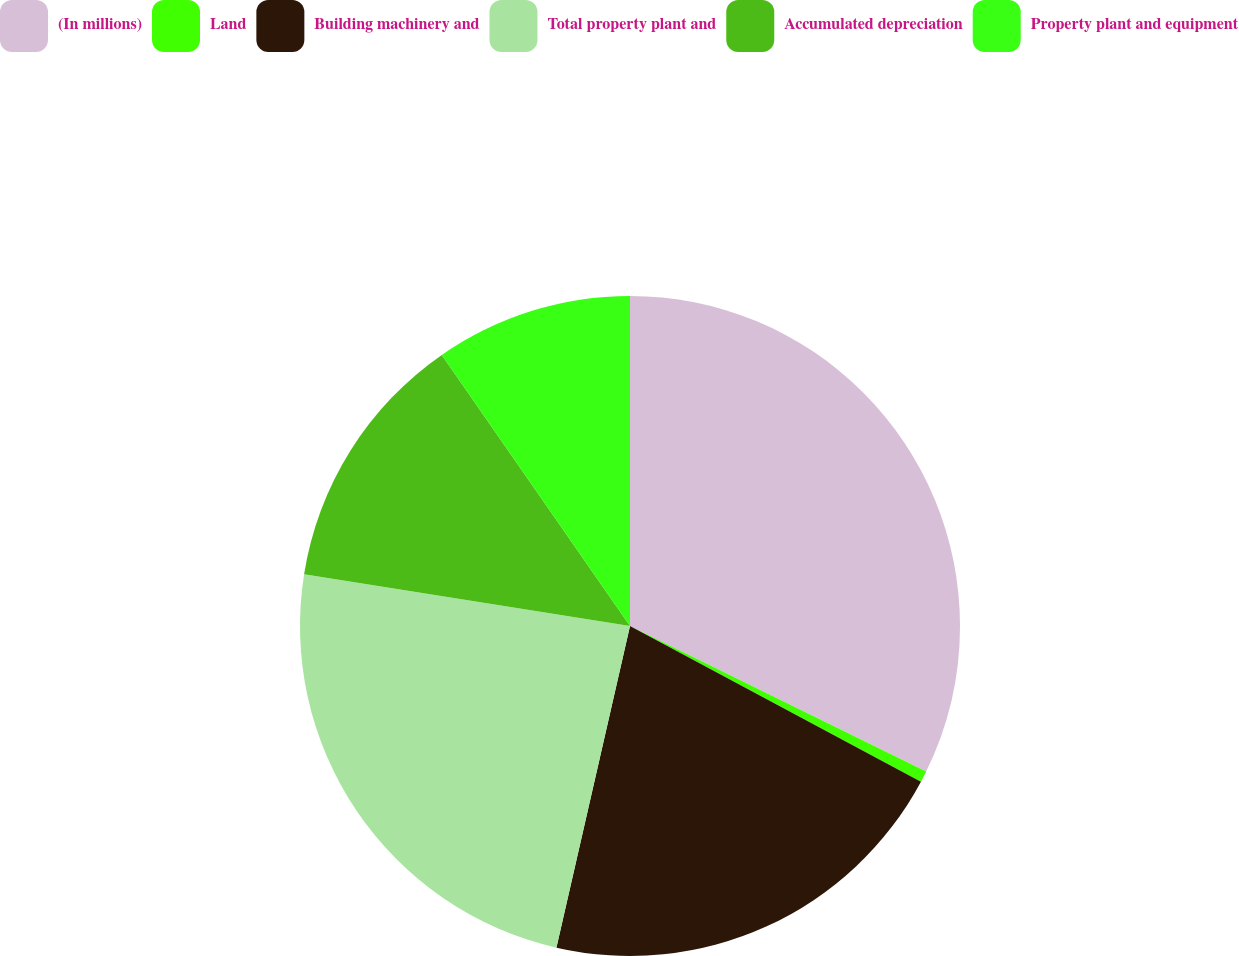Convert chart to OTSL. <chart><loc_0><loc_0><loc_500><loc_500><pie_chart><fcel>(In millions)<fcel>Land<fcel>Building machinery and<fcel>Total property plant and<fcel>Accumulated depreciation<fcel>Property plant and equipment<nl><fcel>32.27%<fcel>0.55%<fcel>20.76%<fcel>23.93%<fcel>12.83%<fcel>9.66%<nl></chart> 